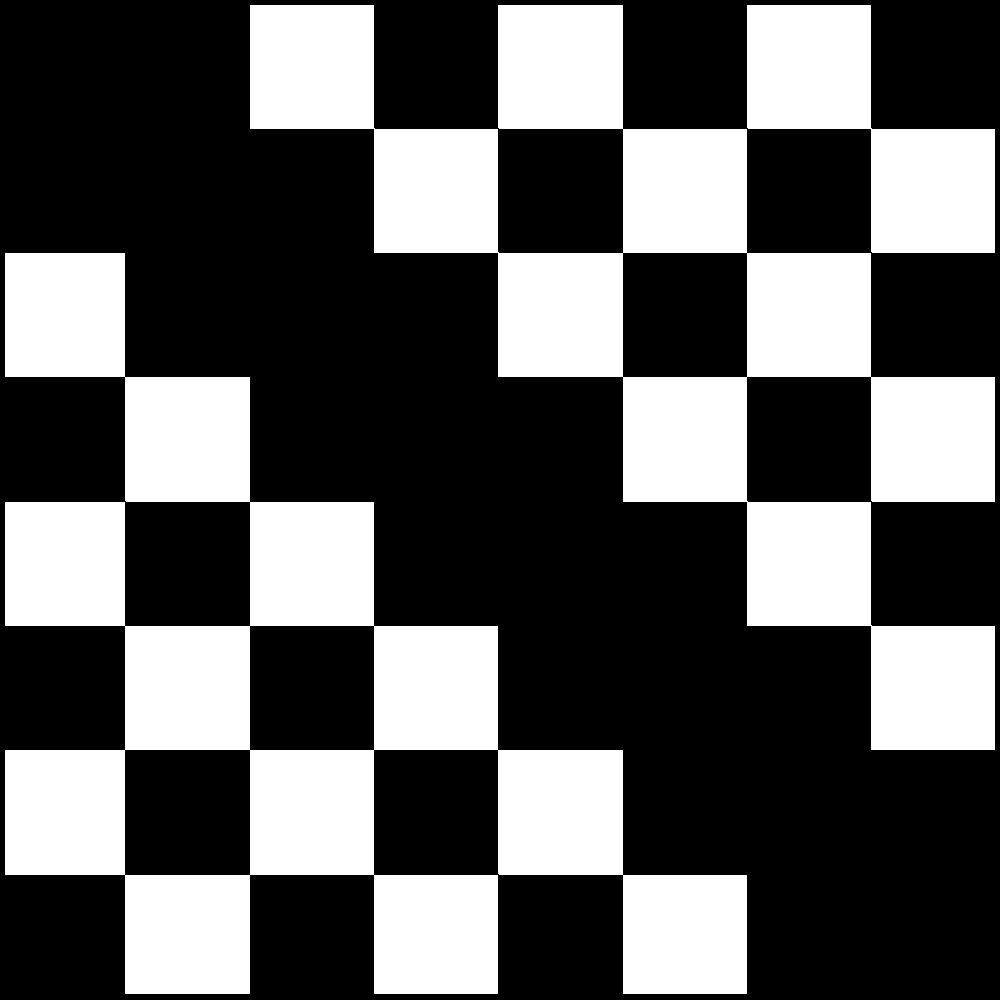In the context of microprocessor design, consider the 8x8 grid of black and white squares above as a representation of binary data. Each black square represents a 1, and each white square represents a 0. What is the decimal equivalent of the binary number formed by reading the diagonal from top-left to bottom-right? Let's approach this step-by-step:

1) First, we need to identify the diagonal from top-left to bottom-right. This diagonal consists of 8 squares.

2) Reading from top-left to bottom-right, we observe the following pattern:
   Black, Black, Black, Black, Black, Black, Black, Black

3) Translating this to binary, we get:
   1 1 1 1 1 1 1 1

4) Now, we need to convert this 8-bit binary number to decimal. In binary, each position represents a power of 2, starting from 2^0 on the right and increasing to the left.

5) So, our binary number represents:
   $$(1 \times 2^7) + (1 \times 2^6) + (1 \times 2^5) + (1 \times 2^4) + (1 \times 2^3) + (1 \times 2^2) + (1 \times 2^1) + (1 \times 2^0)$$

6) Calculating this:
   $$128 + 64 + 32 + 16 + 8 + 4 + 2 + 1 = 255$$

Therefore, the decimal equivalent of the binary number formed by the diagonal is 255.
Answer: 255 